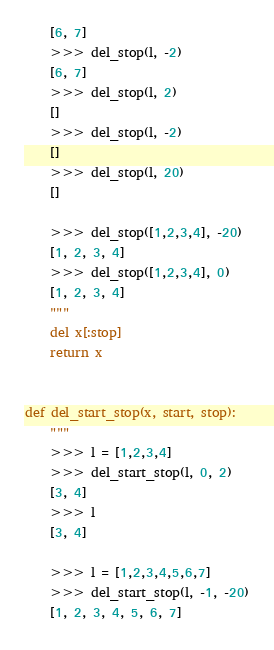<code> <loc_0><loc_0><loc_500><loc_500><_Python_>    [6, 7]
    >>> del_stop(l, -2)
    [6, 7]
    >>> del_stop(l, 2)
    []
    >>> del_stop(l, -2)
    []
    >>> del_stop(l, 20)
    []

    >>> del_stop([1,2,3,4], -20)
    [1, 2, 3, 4]
    >>> del_stop([1,2,3,4], 0)
    [1, 2, 3, 4]
    """
    del x[:stop]
    return x


def del_start_stop(x, start, stop):
    """
    >>> l = [1,2,3,4]
    >>> del_start_stop(l, 0, 2)
    [3, 4]
    >>> l
    [3, 4]

    >>> l = [1,2,3,4,5,6,7]
    >>> del_start_stop(l, -1, -20)
    [1, 2, 3, 4, 5, 6, 7]</code> 